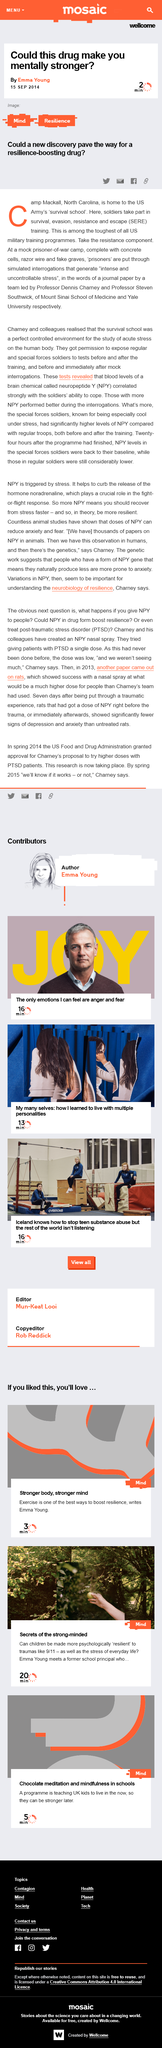Specify some key components in this picture. Professors Dennis Charney and Steven Southwick lead the organization. The "Where is home to the U.S. Army survival school?" is located in Camp Mackell, North Carolina. SERE training is a program designed to prepare individuals for the survival, evasion, resistance, and escape of adverse situations. 